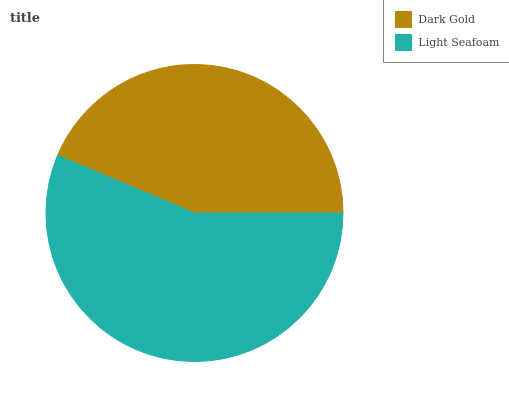Is Dark Gold the minimum?
Answer yes or no. Yes. Is Light Seafoam the maximum?
Answer yes or no. Yes. Is Light Seafoam the minimum?
Answer yes or no. No. Is Light Seafoam greater than Dark Gold?
Answer yes or no. Yes. Is Dark Gold less than Light Seafoam?
Answer yes or no. Yes. Is Dark Gold greater than Light Seafoam?
Answer yes or no. No. Is Light Seafoam less than Dark Gold?
Answer yes or no. No. Is Light Seafoam the high median?
Answer yes or no. Yes. Is Dark Gold the low median?
Answer yes or no. Yes. Is Dark Gold the high median?
Answer yes or no. No. Is Light Seafoam the low median?
Answer yes or no. No. 